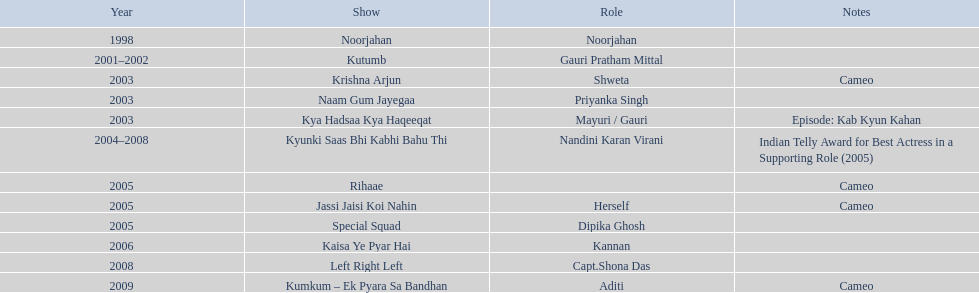The display above left right left Kaisa Ye Pyar Hai. 